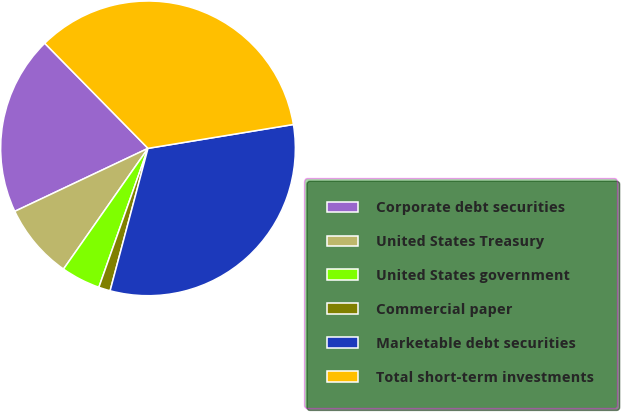Convert chart. <chart><loc_0><loc_0><loc_500><loc_500><pie_chart><fcel>Corporate debt securities<fcel>United States Treasury<fcel>United States government<fcel>Commercial paper<fcel>Marketable debt securities<fcel>Total short-term investments<nl><fcel>19.67%<fcel>8.25%<fcel>4.31%<fcel>1.27%<fcel>31.73%<fcel>34.77%<nl></chart> 